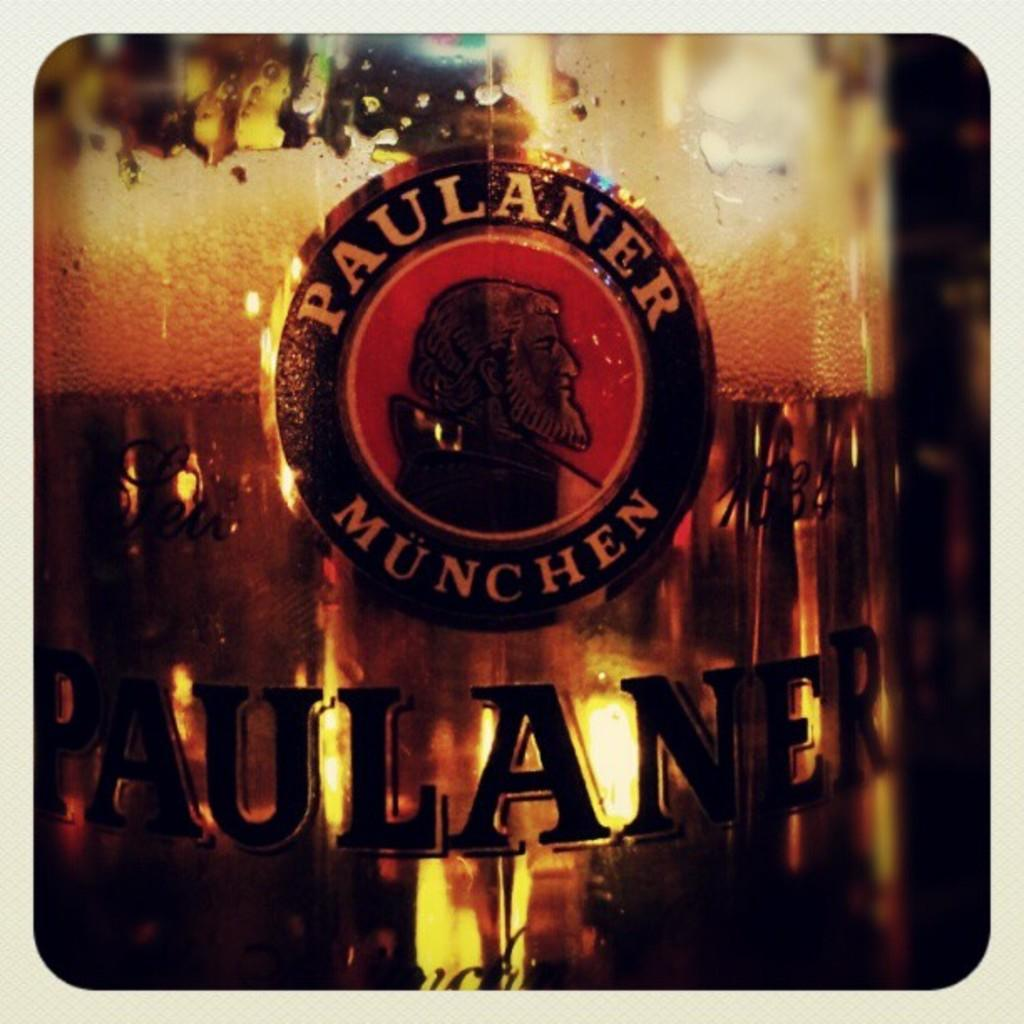<image>
Summarize the visual content of the image. A picture of the trademark of a beer called Paulaner Munchen. 